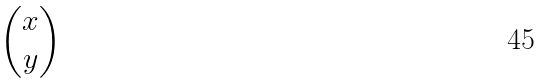Convert formula to latex. <formula><loc_0><loc_0><loc_500><loc_500>\begin{pmatrix} x \\ y \\ \end{pmatrix}</formula> 